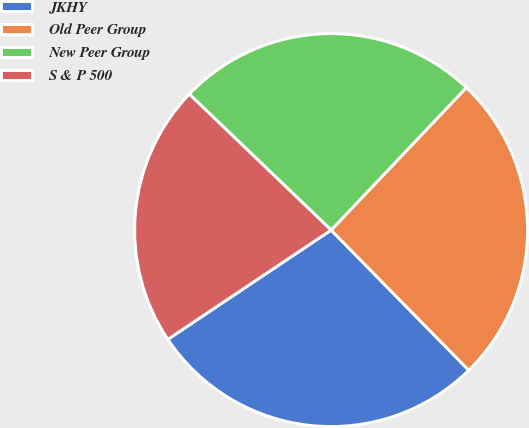<chart> <loc_0><loc_0><loc_500><loc_500><pie_chart><fcel>JKHY<fcel>Old Peer Group<fcel>New Peer Group<fcel>S & P 500<nl><fcel>27.97%<fcel>25.56%<fcel>24.92%<fcel>21.55%<nl></chart> 